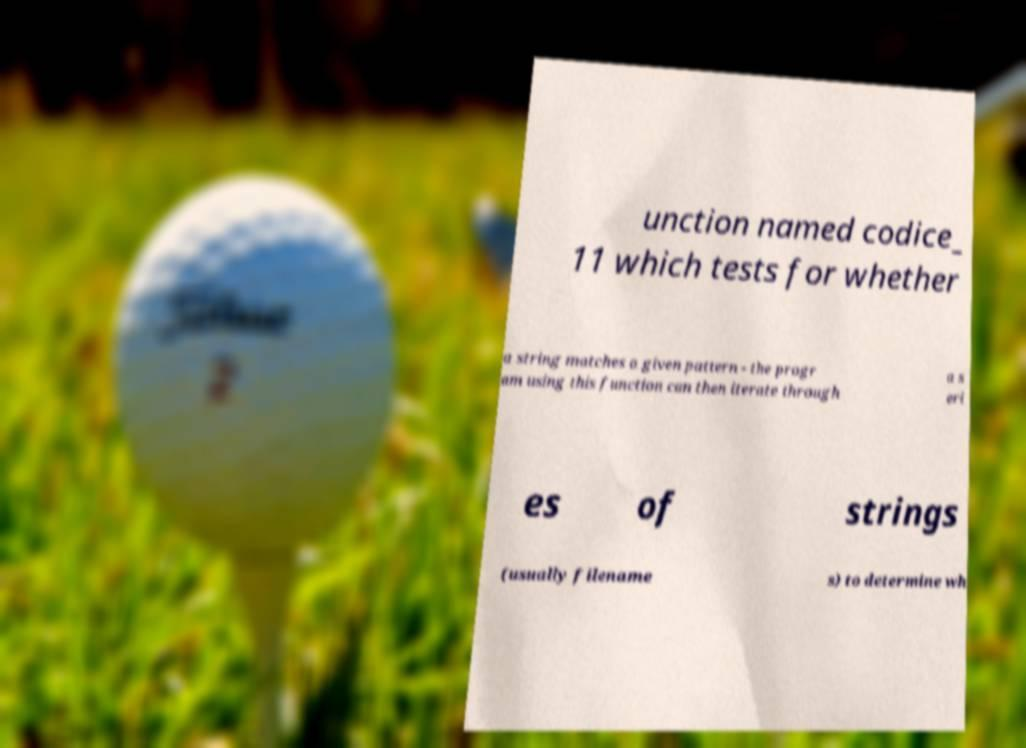I need the written content from this picture converted into text. Can you do that? unction named codice_ 11 which tests for whether a string matches a given pattern - the progr am using this function can then iterate through a s eri es of strings (usually filename s) to determine wh 